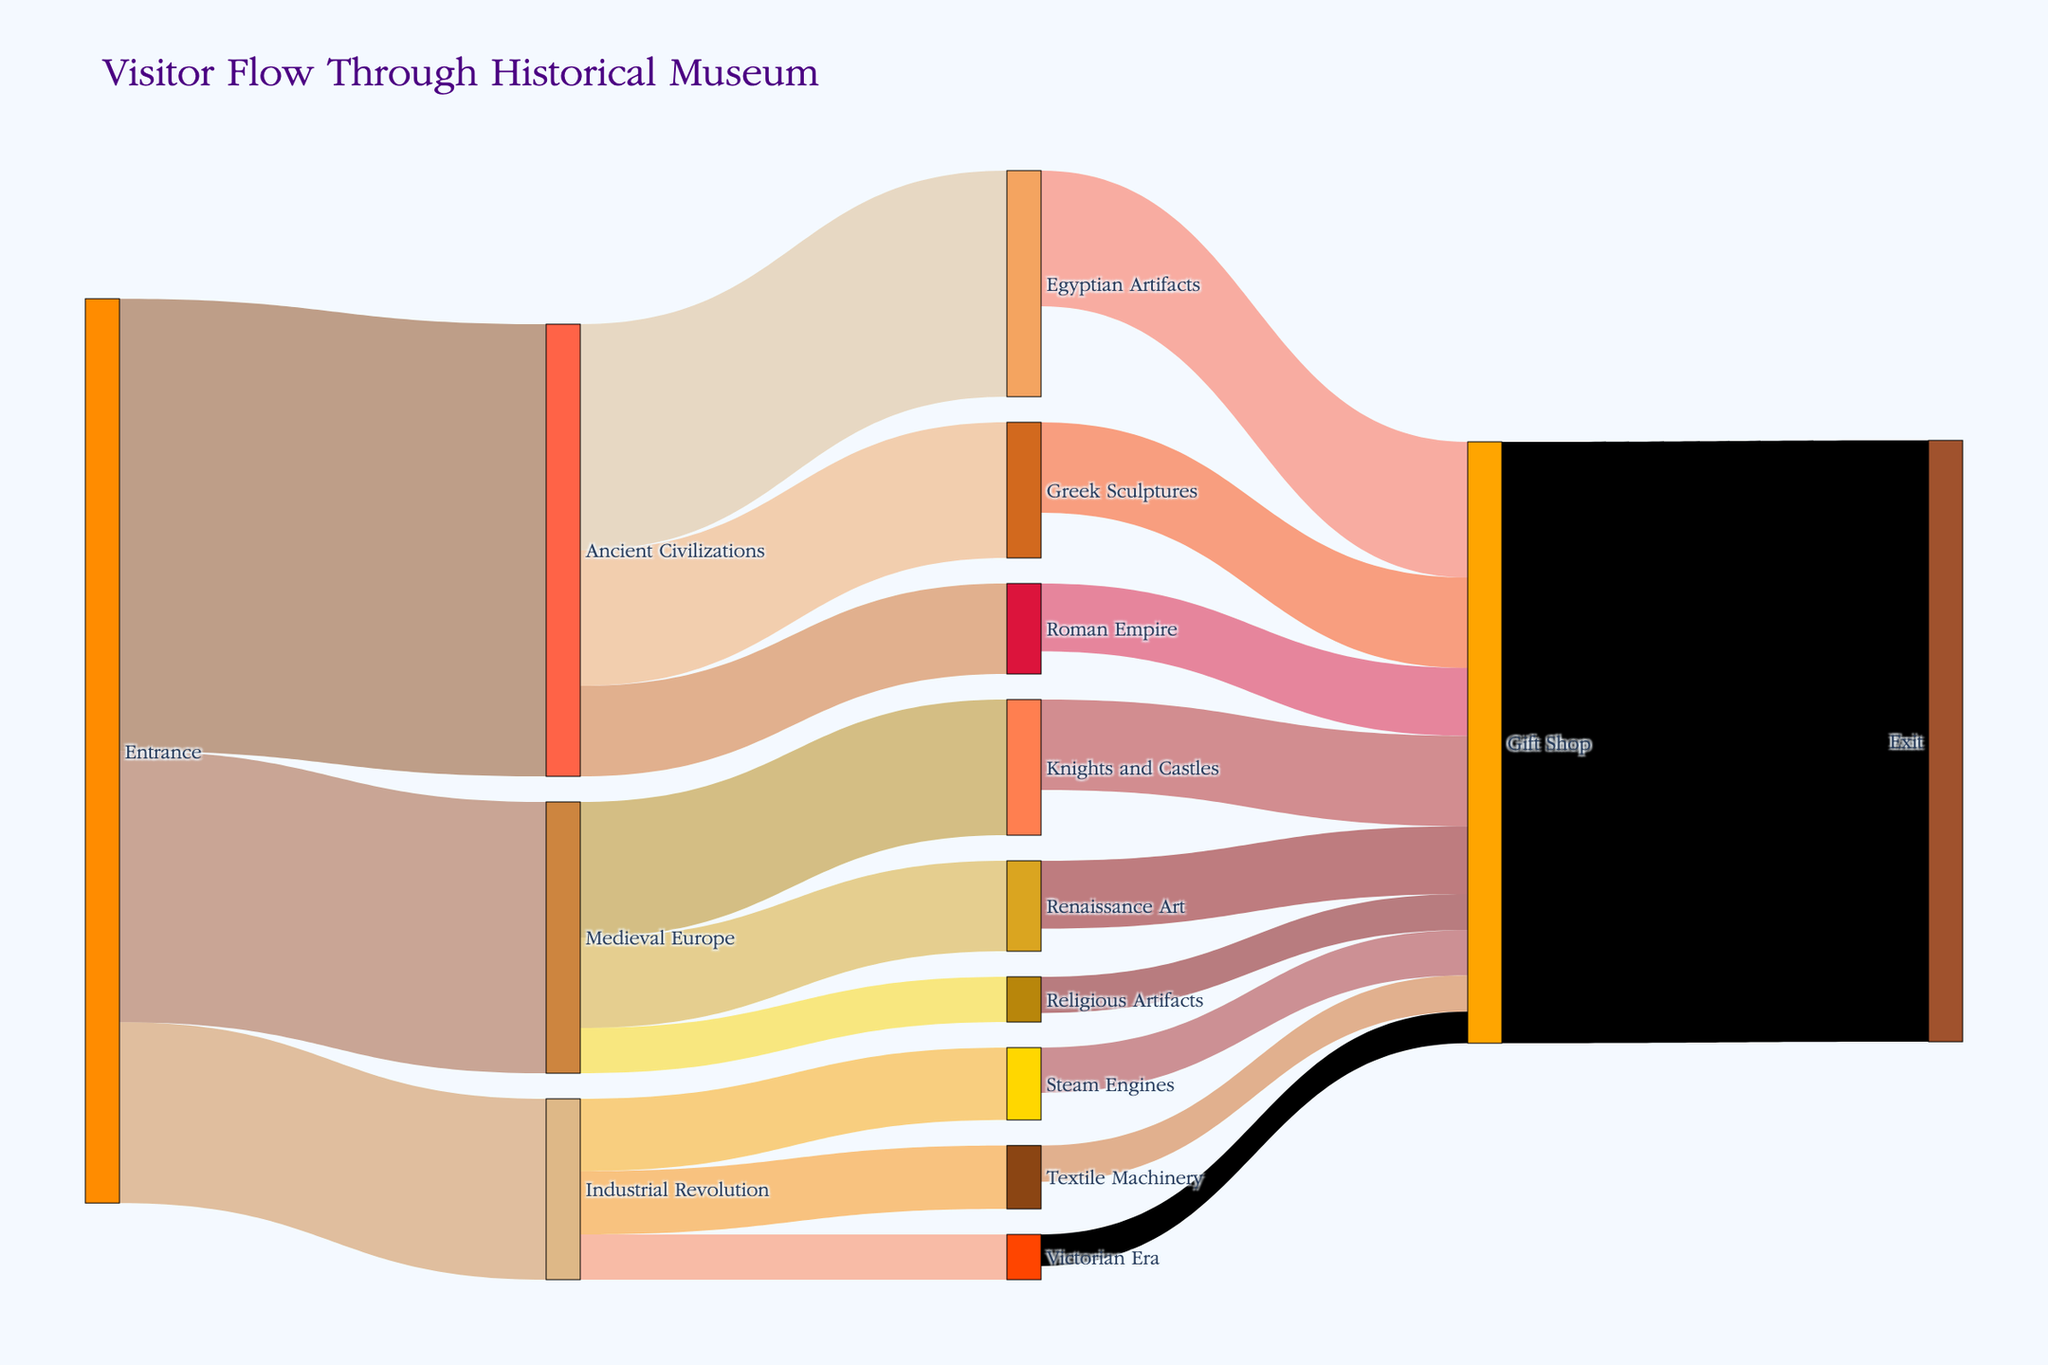what is the most visited exhibit directly from the Entrance? Look at the links originating from the Entrance node, the exhibit with the highest value is Ancient Civilizations.
Answer: Ancient Civilizations how many visitors moved from Ancient Civilizations to Greek Sculptures? Find the link between Ancient Civilizations and Greek Sculptures and refer to its value.
Answer: 150 what is the total number of visitors that went to the Gift Shop? Sum the values of all links leading to the Gift Shop from various exhibits: (150 + 100 + 75 + 100 + 75 + 40 + 50 + 40 + 35) = 665.
Answer: 665 how many more visitors went from the Industrial Revolution area to the Gift Shop compared to the Victorians Era exhibit? Find the values for Industrial Revolution to Gift Shop (50) and Victorian Era to Gift Shop (35), and subtract the second from the first (50 - 35 = 15).
Answer: 15 which exhibit receives fewer visitors directly from Medieval Europe: Knights and Castles or Religious Artifacts? Compare the values for links from Medieval Europe to Knights and Castles (150) and to Religious Artifacts (50). The one with the lower value is the answer.
Answer: Religious Artifacts what percentage of visitors from the Entrance went directly to the Industrial Revolution? Divide the number of visitors from the Entrance to the Industrial Revolution (200) by the total visitors from the Entrance (500 + 300 + 200 = 1000) and multiply by 100 to get the percentage. (200/1000 * 100 = 20%).
Answer: 20% how many visitors exited the museum after visiting the Gift Shop? Refer to the value of the link from the Gift Shop to Exit.
Answer: 665 which exhibit has the least visitor flow from Ancient Civilizations, Egyptian Artifacts, Greek Sculptures, or Roman Empire? Compare the values for links from Ancient Civilizations to Egyptian Artifacts (250), Greek Sculptures (150), and Roman Empire (100). The one with the lowest value is the answer.
Answer: Roman Empire how many visitors flowed through both the Egyptian Artifacts and the Gift Shop by summing only unique visitors? All visitors from Egyptian Artifacts went to the Gift Shop (150) and visitors from Entrance to Ancient Civilizations (500) passed through multiple exhibits, so sum only Egyptian Artifacts -> Gift Shop (150) which are unique visitors.
Answer: 150 